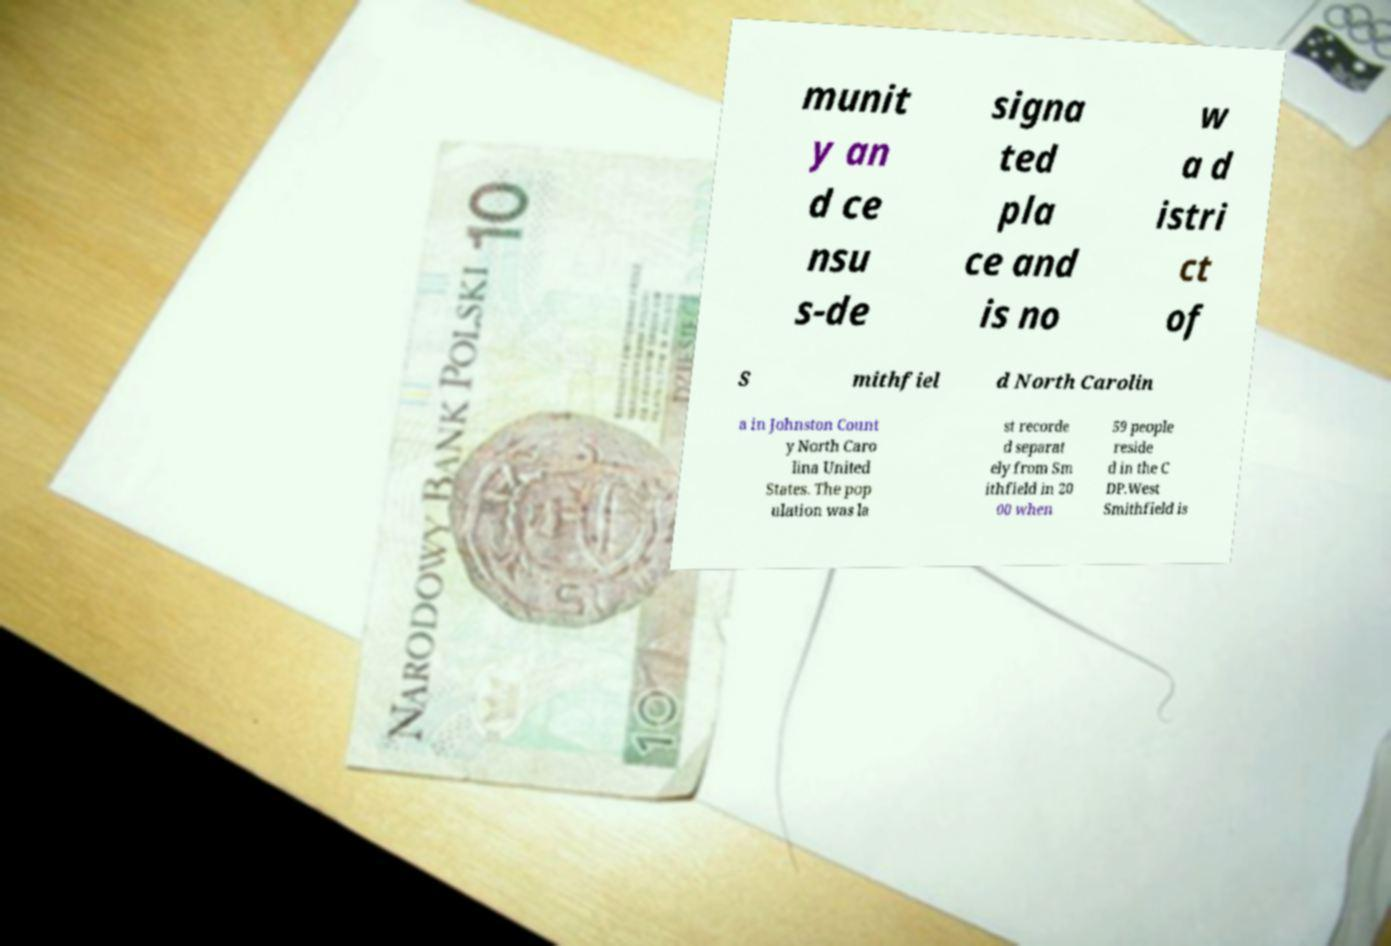Can you read and provide the text displayed in the image?This photo seems to have some interesting text. Can you extract and type it out for me? munit y an d ce nsu s-de signa ted pla ce and is no w a d istri ct of S mithfiel d North Carolin a in Johnston Count y North Caro lina United States. The pop ulation was la st recorde d separat ely from Sm ithfield in 20 00 when 59 people reside d in the C DP.West Smithfield is 